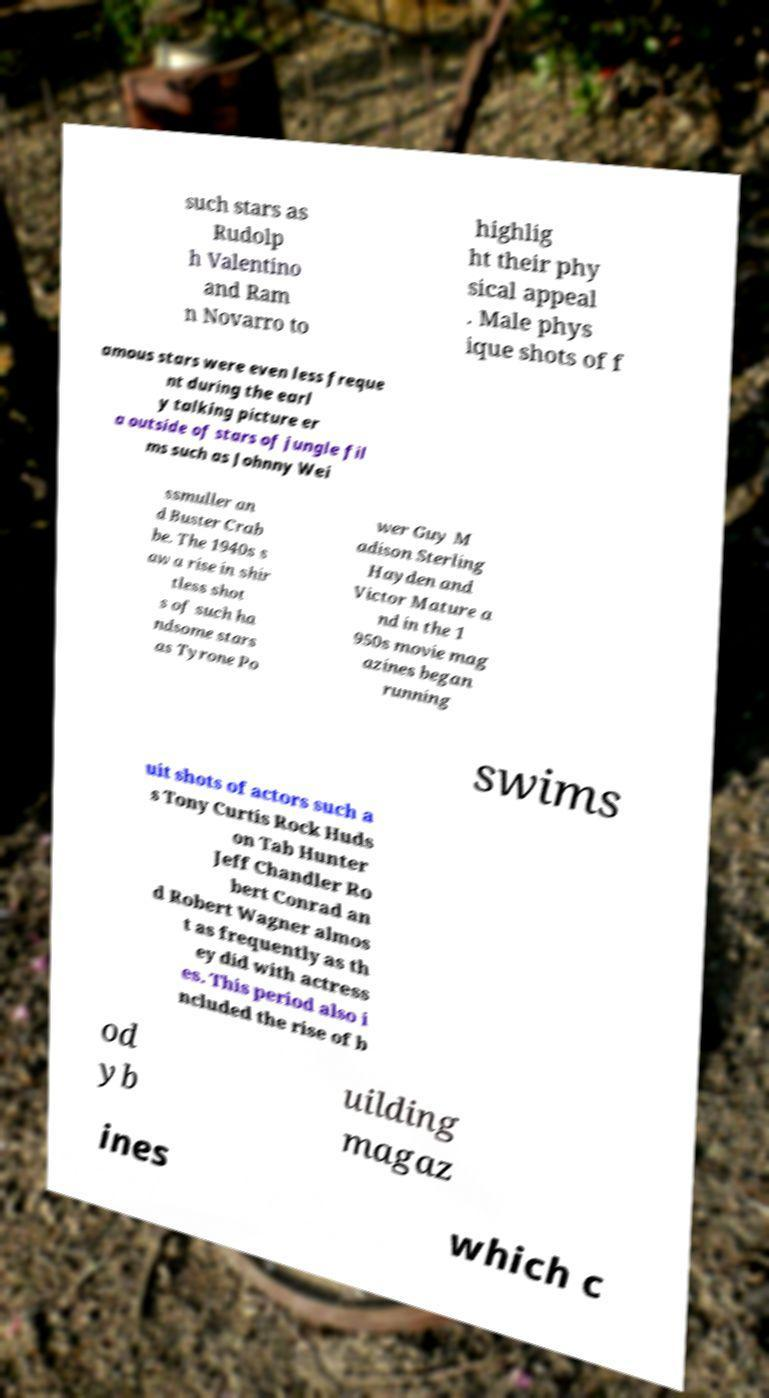What messages or text are displayed in this image? I need them in a readable, typed format. such stars as Rudolp h Valentino and Ram n Novarro to highlig ht their phy sical appeal . Male phys ique shots of f amous stars were even less freque nt during the earl y talking picture er a outside of stars of jungle fil ms such as Johnny Wei ssmuller an d Buster Crab be. The 1940s s aw a rise in shir tless shot s of such ha ndsome stars as Tyrone Po wer Guy M adison Sterling Hayden and Victor Mature a nd in the 1 950s movie mag azines began running swims uit shots of actors such a s Tony Curtis Rock Huds on Tab Hunter Jeff Chandler Ro bert Conrad an d Robert Wagner almos t as frequently as th ey did with actress es. This period also i ncluded the rise of b od yb uilding magaz ines which c 